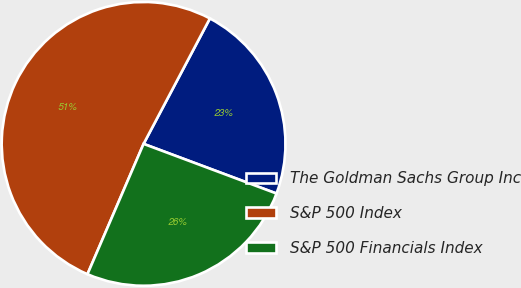Convert chart. <chart><loc_0><loc_0><loc_500><loc_500><pie_chart><fcel>The Goldman Sachs Group Inc<fcel>S&P 500 Index<fcel>S&P 500 Financials Index<nl><fcel>22.95%<fcel>51.27%<fcel>25.78%<nl></chart> 